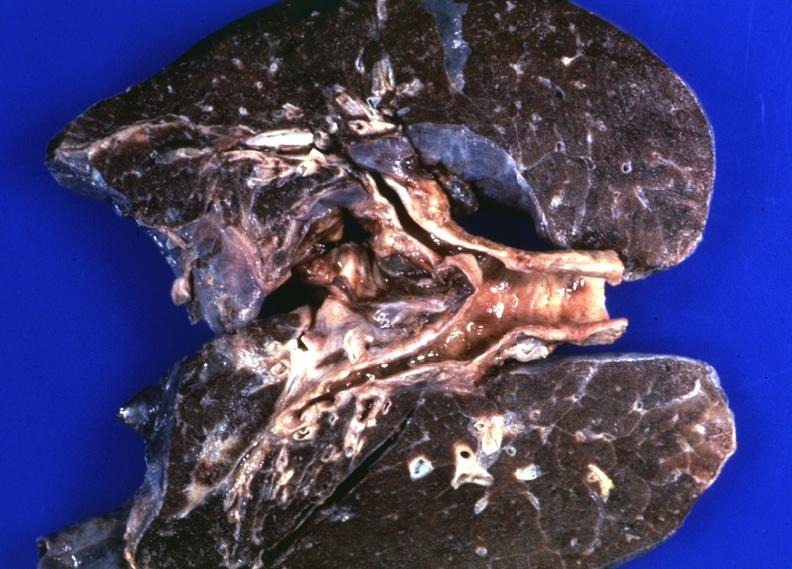where is this?
Answer the question using a single word or phrase. Lung 